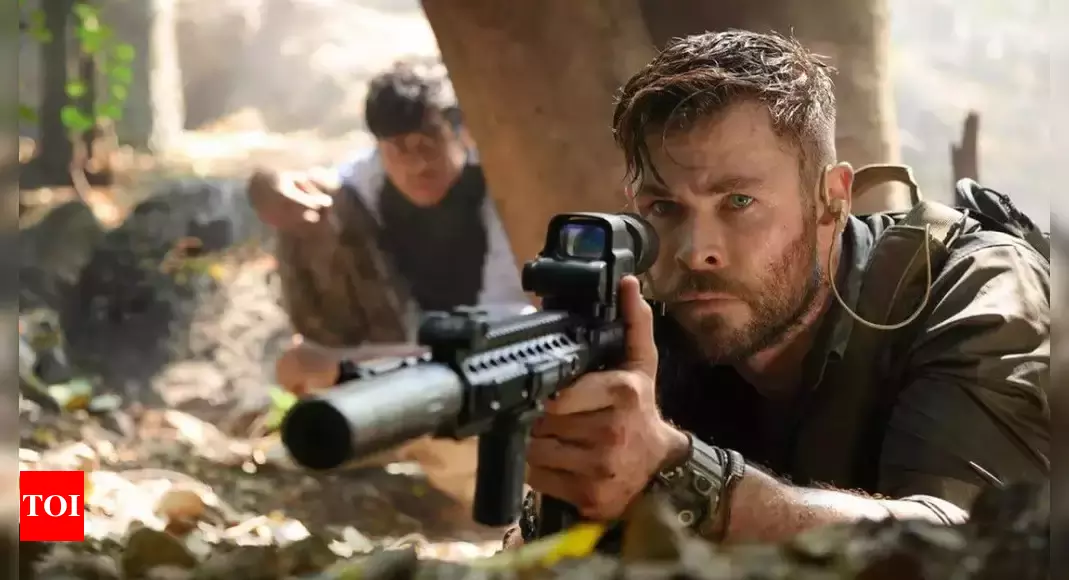If this image were part of a mythical legend, what would be the legend's story? In a mythical legend, the image portrays heroes on a sacred quest in the Enchanted Forest of Eternity. The central figure is Aelric the Valiant, a warrior chosen by the ancient spirits to retrieve the Heart of the Forest, a mystical gem that holds the essence of the natural world. Aelric, armed with the Celestial Rifle of Truth, must navigate through the forest teeming with legendary creatures and malevolent spirits. His companion, a shape-shifter named Ithari, mirrors his actions in her human form, ready to transform into formidable beasts to protect Aelric. Together, they face trials set by forest guardians, unraveling age-old enigmas and battling spectral enemies. Their journey is one not only of physical endurance but also of wisdom and heart, as they must earn the forest's trust to reclaim its heart and restore balance to their world. Can you create a short, realistic scenario based on this image? Tyler Rake and his partner hunker down behind a tree in the dense jungle, their eyes scanning the surroundings for any movement. The sunlight filters through the canopy, casting shadows that dance with the breeze. Their mission: to extract a high-value target hidden deep within enemy territory. Every rustle and crack raises their alertness, the tension palpable as they move with calculated precision, communicating through barely audible signals. Rake checks his rifle's scope, ensuring they're ready for whatever comes next. It's a high-stakes game of cat and mouse, where their every move could mean the difference between life and death. 